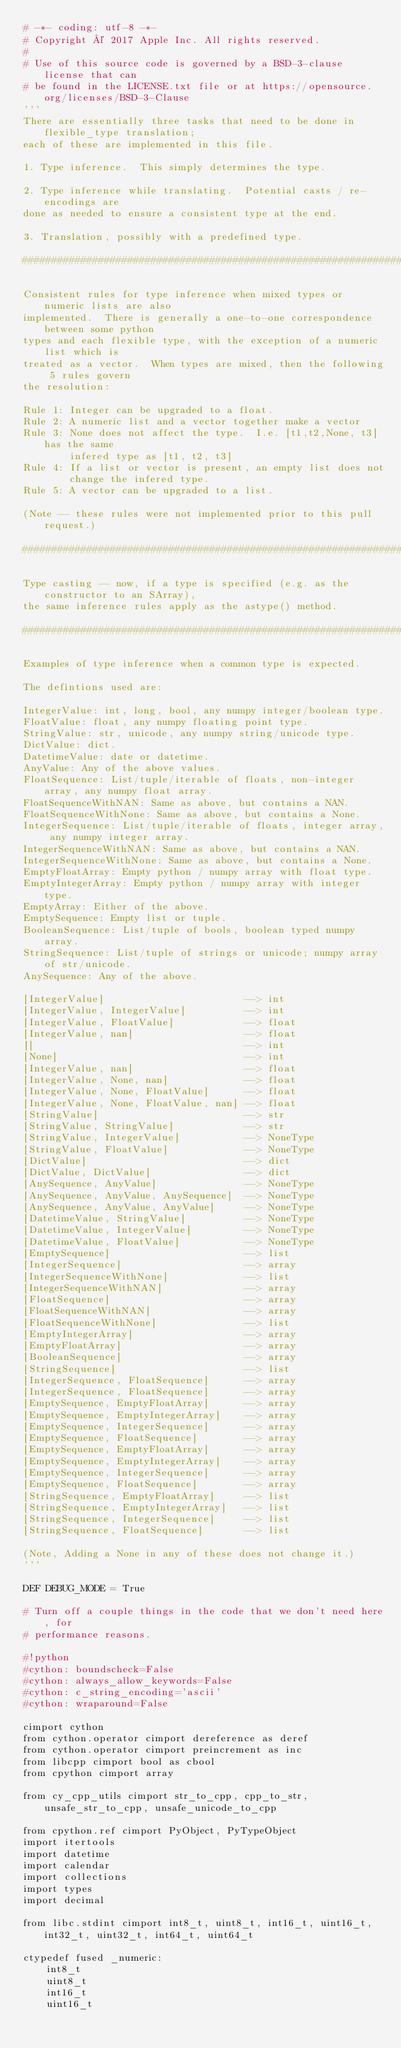<code> <loc_0><loc_0><loc_500><loc_500><_Cython_># -*- coding: utf-8 -*-
# Copyright © 2017 Apple Inc. All rights reserved.
#
# Use of this source code is governed by a BSD-3-clause license that can
# be found in the LICENSE.txt file or at https://opensource.org/licenses/BSD-3-Clause
'''
There are essentially three tasks that need to be done in flexible_type translation;
each of these are implemented in this file.

1. Type inference.  This simply determines the type.

2. Type inference while translating.  Potential casts / re-encodings are
done as needed to ensure a consistent type at the end.

3. Translation, possibly with a predefined type.

################################################################################

Consistent rules for type inference when mixed types or numeric lists are also
implemented.  There is generally a one-to-one correspondence between some python
types and each flexible type, with the exception of a numeric list which is
treated as a vector.  When types are mixed, then the following 5 rules govern
the resolution:

Rule 1: Integer can be upgraded to a float.
Rule 2: A numeric list and a vector together make a vector
Rule 3: None does not affect the type.  I.e. [t1,t2,None, t3] has the same
        infered type as [t1, t2, t3]
Rule 4: If a list or vector is present, an empty list does not
        change the infered type.
Rule 5: A vector can be upgraded to a list.

(Note -- these rules were not implemented prior to this pull request.)

################################################################################

Type casting -- now, if a type is specified (e.g. as the constructor to an SArray),
the same inference rules apply as the astype() method.

################################################################################

Examples of type inference when a common type is expected.

The defintions used are:

IntegerValue: int, long, bool, any numpy integer/boolean type.
FloatValue: float, any numpy floating point type.
StringValue: str, unicode, any numpy string/unicode type.
DictValue: dict.
DatetimeValue: date or datetime.
AnyValue: Any of the above values.
FloatSequence: List/tuple/iterable of floats, non-integer array, any numpy float array.
FloatSequenceWithNAN: Same as above, but contains a NAN.
FloatSequenceWithNone: Same as above, but contains a None.
IntegerSequence: List/tuple/iterable of floats, integer array, any numpy integer array.
IntegerSequenceWithNAN: Same as above, but contains a NAN.
IntegerSequenceWithNone: Same as above, but contains a None.
EmptyFloatArray: Empty python / numpy array with float type.
EmptyIntegerArray: Empty python / numpy array with integer  type.
EmptyArray: Either of the above.
EmptySequence: Empty list or tuple.
BooleanSequence: List/tuple of bools, boolean typed numpy array.
StringSequence: List/tuple of strings or unicode; numpy array of str/unicode.
AnySequence: Any of the above.

[IntegerValue]                        --> int
[IntegerValue, IntegerValue]          --> int
[IntegerValue, FloatValue]            --> float
[IntegerValue, nan]                   --> float
[]                                    --> int
[None]                                --> int
[IntegerValue, nan]                   --> float
[IntegerValue, None, nan]             --> float
[IntegerValue, None, FloatValue]      --> float
[IntegerValue, None, FloatValue, nan] --> float
[StringValue]                         --> str
[StringValue, StringValue]            --> str
[StringValue, IntegerValue]           --> NoneType
[StringValue, FloatValue]             --> NoneType
[DictValue]                           --> dict
[DictValue, DictValue]                --> dict
[AnySequence, AnyValue]               --> NoneType
[AnySequence, AnyValue, AnySequence]  --> NoneType
[AnySequence, AnyValue, AnyValue]     --> NoneType
[DatetimeValue, StringValue]          --> NoneType
[DatetimeValue, IntegerValue]         --> NoneType
[DatetimeValue, FloatValue]           --> NoneType
[EmptySequence]                       --> list
[IntegerSequence]                     --> array
[IntegerSequenceWithNone]             --> list
[IntegerSequenceWithNAN]              --> array
[FloatSequence]                       --> array
[FloatSequenceWithNAN]                --> array
[FloatSequenceWithNone]               --> list
[EmptyIntegerArray]                   --> array
[EmptyFloatArray]                     --> array
[BooleanSequence]                     --> array
[StringSequence]                      --> list
[IntegerSequence, FloatSequence]      --> array
[IntegerSequence, FloatSequence]      --> array
[EmptySequence, EmptyFloatArray]      --> array
[EmptySequence, EmptyIntegerArray]    --> array
[EmptySequence, IntegerSequence]      --> array
[EmptySequence, FloatSequence]        --> array
[EmptySequence, EmptyFloatArray]      --> array
[EmptySequence, EmptyIntegerArray]    --> array
[EmptySequence, IntegerSequence]      --> array
[EmptySequence, FloatSequence]        --> array
[StringSequence, EmptyFloatArray]     --> list
[StringSequence, EmptyIntegerArray]   --> list
[StringSequence, IntegerSequence]     --> list
[StringSequence, FloatSequence]       --> list

(Note, Adding a None in any of these does not change it.)
'''

DEF DEBUG_MODE = True

# Turn off a couple things in the code that we don't need here, for
# performance reasons.

#!python
#cython: boundscheck=False
#cython: always_allow_keywords=False
#cython: c_string_encoding='ascii'
#cython: wraparound=False

cimport cython
from cython.operator cimport dereference as deref
from cython.operator cimport preincrement as inc
from libcpp cimport bool as cbool
from cpython cimport array

from cy_cpp_utils cimport str_to_cpp, cpp_to_str, unsafe_str_to_cpp, unsafe_unicode_to_cpp

from cpython.ref cimport PyObject, PyTypeObject
import itertools
import datetime
import calendar
import collections
import types
import decimal

from libc.stdint cimport int8_t, uint8_t, int16_t, uint16_t, int32_t, uint32_t, int64_t, uint64_t

ctypedef fused _numeric:
    int8_t
    uint8_t
    int16_t
    uint16_t</code> 